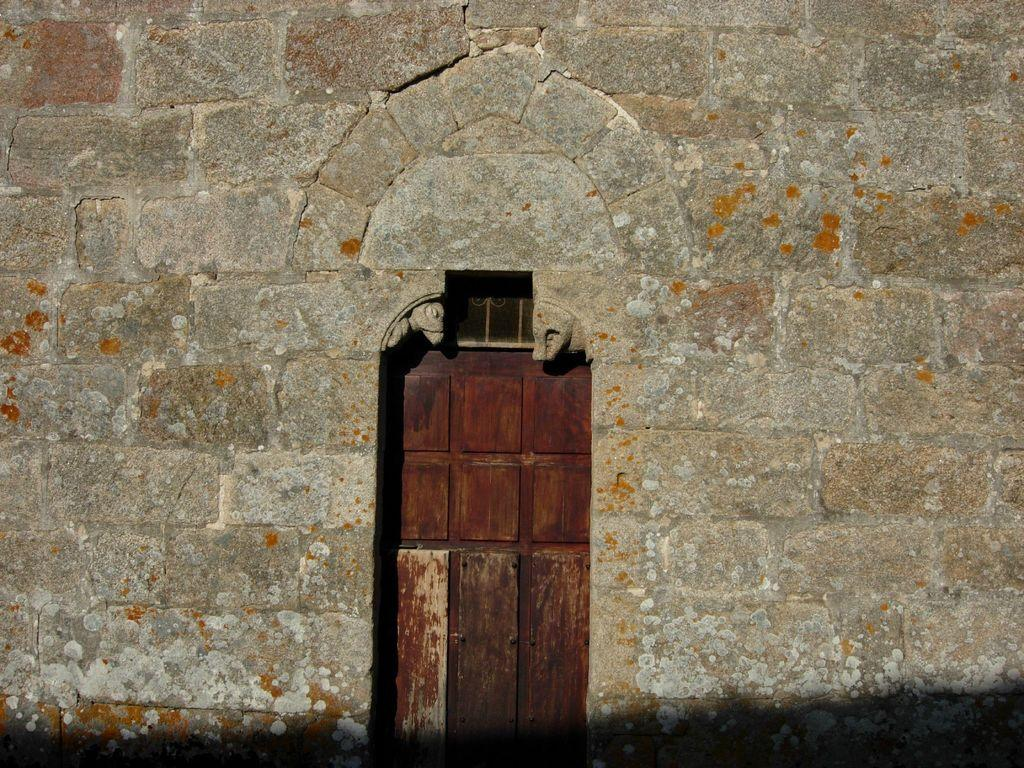What type of structure can be seen in the image? There is a door and a wall in the image. Can you describe the door in the image? The door is a part of the structure visible in the image. What else can be seen in the image besides the door? There is also a wall in the image. What type of pan is hanging on the wall in the image? There is no pan visible in the image; only a door and a wall are present. What is the texture of the room in the image? The image only shows a door and a wall, so it is not possible to determine the texture of the room. 